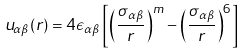Convert formula to latex. <formula><loc_0><loc_0><loc_500><loc_500>u _ { \alpha \beta } ( r ) = 4 \epsilon _ { \alpha \beta } \left [ { \left ( \frac { \sigma _ { \alpha \beta } } { r } \right ) } ^ { m } - { \left ( \frac { \sigma _ { \alpha \beta } } { r } \right ) } ^ { 6 } \right ]</formula> 